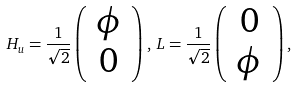<formula> <loc_0><loc_0><loc_500><loc_500>H _ { u } = \frac { 1 } { \sqrt { 2 } } \left ( \begin{array} { c } \phi \\ 0 \end{array} \right ) , \, L = \frac { 1 } { \sqrt { 2 } } \left ( \begin{array} { c } 0 \\ \phi \end{array} \right ) ,</formula> 